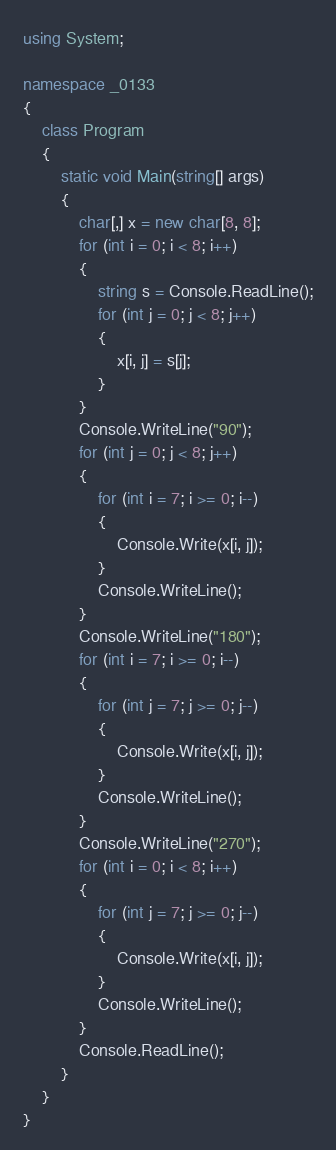Convert code to text. <code><loc_0><loc_0><loc_500><loc_500><_C#_>using System;

namespace _0133
{
    class Program
    {
        static void Main(string[] args)
        {
            char[,] x = new char[8, 8];
            for (int i = 0; i < 8; i++)
            {
                string s = Console.ReadLine();
                for (int j = 0; j < 8; j++)
                {
                    x[i, j] = s[j];
                }
            }
            Console.WriteLine("90");
            for (int j = 0; j < 8; j++)
            {
                for (int i = 7; i >= 0; i--)
                {
                    Console.Write(x[i, j]);
                }
                Console.WriteLine();
            }
            Console.WriteLine("180");
            for (int i = 7; i >= 0; i--)
            {
                for (int j = 7; j >= 0; j--)
                {
                    Console.Write(x[i, j]);
                }
                Console.WriteLine();
            }
            Console.WriteLine("270");
            for (int i = 0; i < 8; i++)
            {
                for (int j = 7; j >= 0; j--)
                {
                    Console.Write(x[i, j]);
                }
                Console.WriteLine();
            }
            Console.ReadLine();
        }
    }
}</code> 